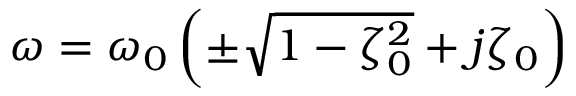Convert formula to latex. <formula><loc_0><loc_0><loc_500><loc_500>\omega = \omega _ { 0 } \left ( \pm \sqrt { 1 - \zeta _ { 0 } ^ { 2 } } + j \zeta _ { 0 } \right )</formula> 